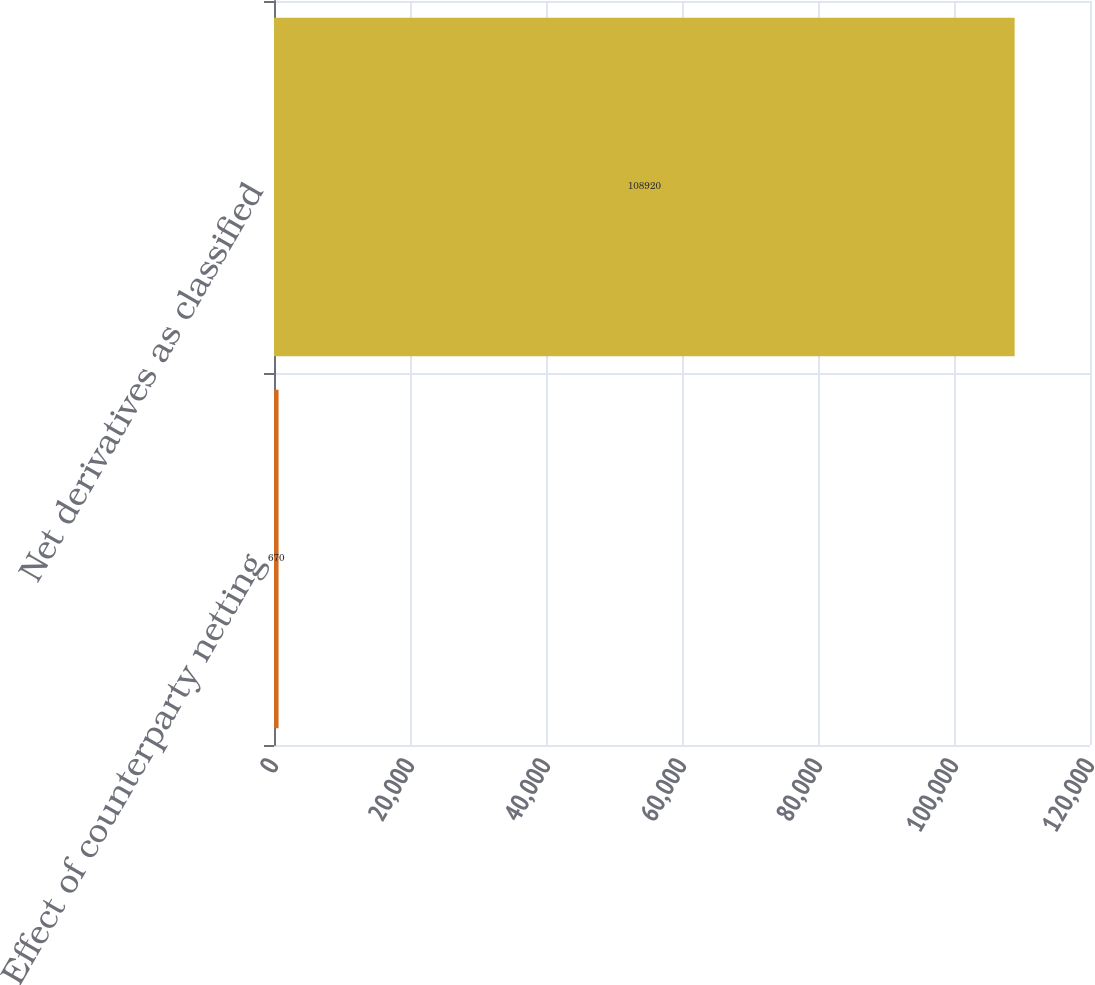Convert chart. <chart><loc_0><loc_0><loc_500><loc_500><bar_chart><fcel>Effect of counterparty netting<fcel>Net derivatives as classified<nl><fcel>670<fcel>108920<nl></chart> 